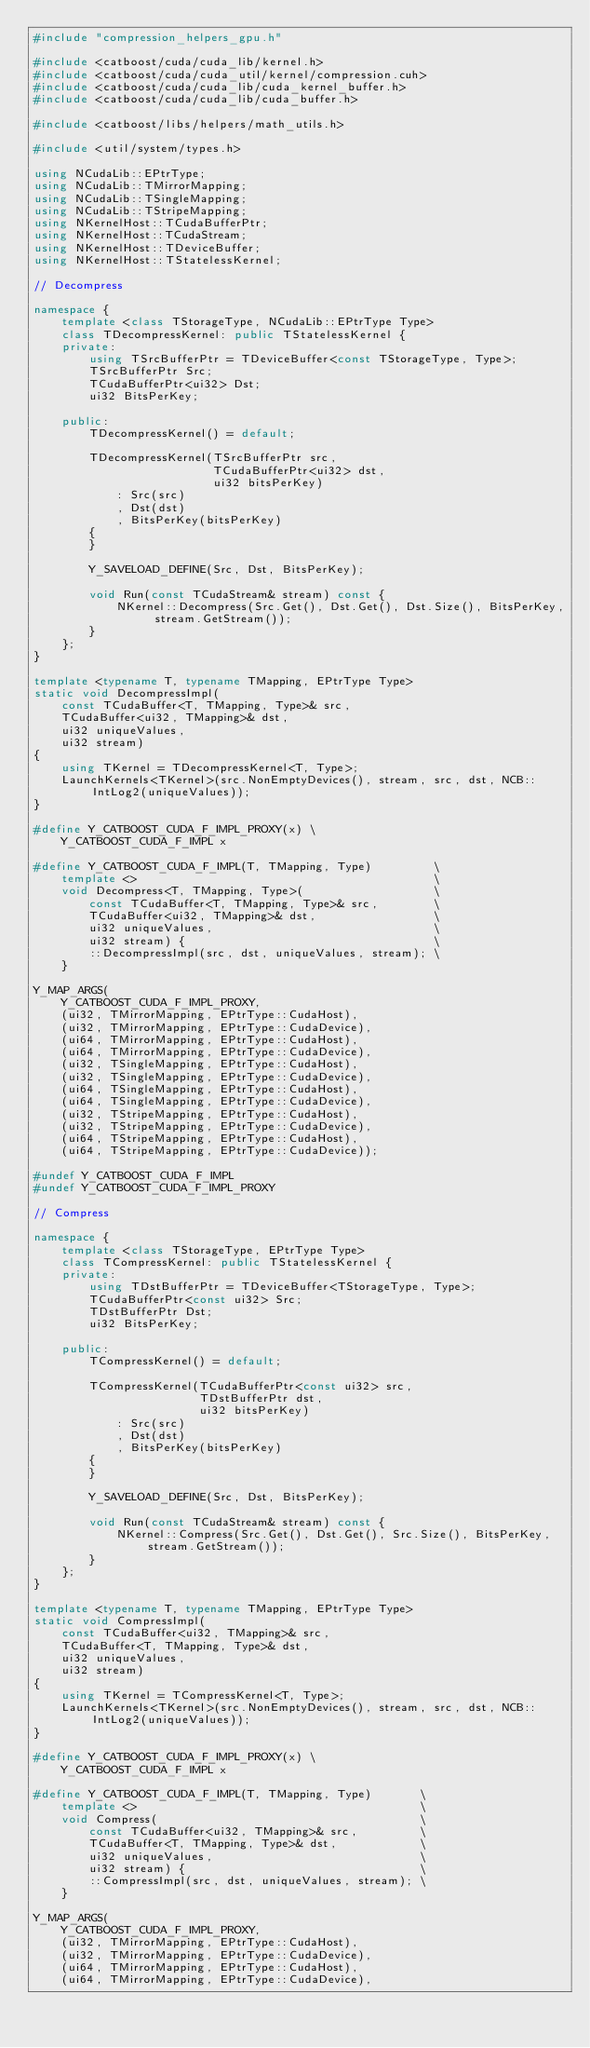<code> <loc_0><loc_0><loc_500><loc_500><_C++_>#include "compression_helpers_gpu.h"

#include <catboost/cuda/cuda_lib/kernel.h>
#include <catboost/cuda/cuda_util/kernel/compression.cuh>
#include <catboost/cuda/cuda_lib/cuda_kernel_buffer.h>
#include <catboost/cuda/cuda_lib/cuda_buffer.h>

#include <catboost/libs/helpers/math_utils.h>

#include <util/system/types.h>

using NCudaLib::EPtrType;
using NCudaLib::TMirrorMapping;
using NCudaLib::TSingleMapping;
using NCudaLib::TStripeMapping;
using NKernelHost::TCudaBufferPtr;
using NKernelHost::TCudaStream;
using NKernelHost::TDeviceBuffer;
using NKernelHost::TStatelessKernel;

// Decompress

namespace {
    template <class TStorageType, NCudaLib::EPtrType Type>
    class TDecompressKernel: public TStatelessKernel {
    private:
        using TSrcBufferPtr = TDeviceBuffer<const TStorageType, Type>;
        TSrcBufferPtr Src;
        TCudaBufferPtr<ui32> Dst;
        ui32 BitsPerKey;

    public:
        TDecompressKernel() = default;

        TDecompressKernel(TSrcBufferPtr src,
                          TCudaBufferPtr<ui32> dst,
                          ui32 bitsPerKey)
            : Src(src)
            , Dst(dst)
            , BitsPerKey(bitsPerKey)
        {
        }

        Y_SAVELOAD_DEFINE(Src, Dst, BitsPerKey);

        void Run(const TCudaStream& stream) const {
            NKernel::Decompress(Src.Get(), Dst.Get(), Dst.Size(), BitsPerKey, stream.GetStream());
        }
    };
}

template <typename T, typename TMapping, EPtrType Type>
static void DecompressImpl(
    const TCudaBuffer<T, TMapping, Type>& src,
    TCudaBuffer<ui32, TMapping>& dst,
    ui32 uniqueValues,
    ui32 stream)
{
    using TKernel = TDecompressKernel<T, Type>;
    LaunchKernels<TKernel>(src.NonEmptyDevices(), stream, src, dst, NCB::IntLog2(uniqueValues));
}

#define Y_CATBOOST_CUDA_F_IMPL_PROXY(x) \
    Y_CATBOOST_CUDA_F_IMPL x

#define Y_CATBOOST_CUDA_F_IMPL(T, TMapping, Type)         \
    template <>                                           \
    void Decompress<T, TMapping, Type>(                   \
        const TCudaBuffer<T, TMapping, Type>& src,        \
        TCudaBuffer<ui32, TMapping>& dst,                 \
        ui32 uniqueValues,                                \
        ui32 stream) {                                    \
        ::DecompressImpl(src, dst, uniqueValues, stream); \
    }

Y_MAP_ARGS(
    Y_CATBOOST_CUDA_F_IMPL_PROXY,
    (ui32, TMirrorMapping, EPtrType::CudaHost),
    (ui32, TMirrorMapping, EPtrType::CudaDevice),
    (ui64, TMirrorMapping, EPtrType::CudaHost),
    (ui64, TMirrorMapping, EPtrType::CudaDevice),
    (ui32, TSingleMapping, EPtrType::CudaHost),
    (ui32, TSingleMapping, EPtrType::CudaDevice),
    (ui64, TSingleMapping, EPtrType::CudaHost),
    (ui64, TSingleMapping, EPtrType::CudaDevice),
    (ui32, TStripeMapping, EPtrType::CudaHost),
    (ui32, TStripeMapping, EPtrType::CudaDevice),
    (ui64, TStripeMapping, EPtrType::CudaHost),
    (ui64, TStripeMapping, EPtrType::CudaDevice));

#undef Y_CATBOOST_CUDA_F_IMPL
#undef Y_CATBOOST_CUDA_F_IMPL_PROXY

// Compress

namespace {
    template <class TStorageType, EPtrType Type>
    class TCompressKernel: public TStatelessKernel {
    private:
        using TDstBufferPtr = TDeviceBuffer<TStorageType, Type>;
        TCudaBufferPtr<const ui32> Src;
        TDstBufferPtr Dst;
        ui32 BitsPerKey;

    public:
        TCompressKernel() = default;

        TCompressKernel(TCudaBufferPtr<const ui32> src,
                        TDstBufferPtr dst,
                        ui32 bitsPerKey)
            : Src(src)
            , Dst(dst)
            , BitsPerKey(bitsPerKey)
        {
        }

        Y_SAVELOAD_DEFINE(Src, Dst, BitsPerKey);

        void Run(const TCudaStream& stream) const {
            NKernel::Compress(Src.Get(), Dst.Get(), Src.Size(), BitsPerKey, stream.GetStream());
        }
    };
}

template <typename T, typename TMapping, EPtrType Type>
static void CompressImpl(
    const TCudaBuffer<ui32, TMapping>& src,
    TCudaBuffer<T, TMapping, Type>& dst,
    ui32 uniqueValues,
    ui32 stream)
{
    using TKernel = TCompressKernel<T, Type>;
    LaunchKernels<TKernel>(src.NonEmptyDevices(), stream, src, dst, NCB::IntLog2(uniqueValues));
}

#define Y_CATBOOST_CUDA_F_IMPL_PROXY(x) \
    Y_CATBOOST_CUDA_F_IMPL x

#define Y_CATBOOST_CUDA_F_IMPL(T, TMapping, Type)       \
    template <>                                         \
    void Compress(                                      \
        const TCudaBuffer<ui32, TMapping>& src,         \
        TCudaBuffer<T, TMapping, Type>& dst,            \
        ui32 uniqueValues,                              \
        ui32 stream) {                                  \
        ::CompressImpl(src, dst, uniqueValues, stream); \
    }

Y_MAP_ARGS(
    Y_CATBOOST_CUDA_F_IMPL_PROXY,
    (ui32, TMirrorMapping, EPtrType::CudaHost),
    (ui32, TMirrorMapping, EPtrType::CudaDevice),
    (ui64, TMirrorMapping, EPtrType::CudaHost),
    (ui64, TMirrorMapping, EPtrType::CudaDevice),</code> 